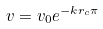Convert formula to latex. <formula><loc_0><loc_0><loc_500><loc_500>v = v _ { 0 } e ^ { - k r _ { c } \pi }</formula> 